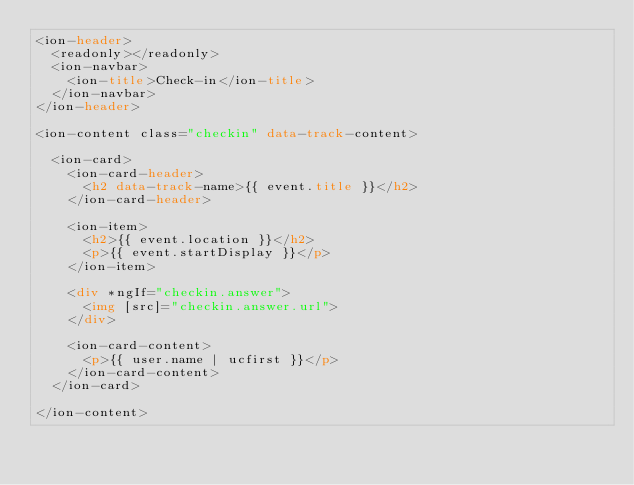Convert code to text. <code><loc_0><loc_0><loc_500><loc_500><_HTML_><ion-header>
  <readonly></readonly>
  <ion-navbar>
    <ion-title>Check-in</ion-title>
  </ion-navbar>
</ion-header>

<ion-content class="checkin" data-track-content>

  <ion-card>
    <ion-card-header>
      <h2 data-track-name>{{ event.title }}</h2>
    </ion-card-header>

    <ion-item>
      <h2>{{ event.location }}</h2>
      <p>{{ event.startDisplay }}</p>
    </ion-item>

    <div *ngIf="checkin.answer">
      <img [src]="checkin.answer.url">
    </div>

    <ion-card-content>
      <p>{{ user.name | ucfirst }}</p>
    </ion-card-content>
  </ion-card>

</ion-content>
</code> 